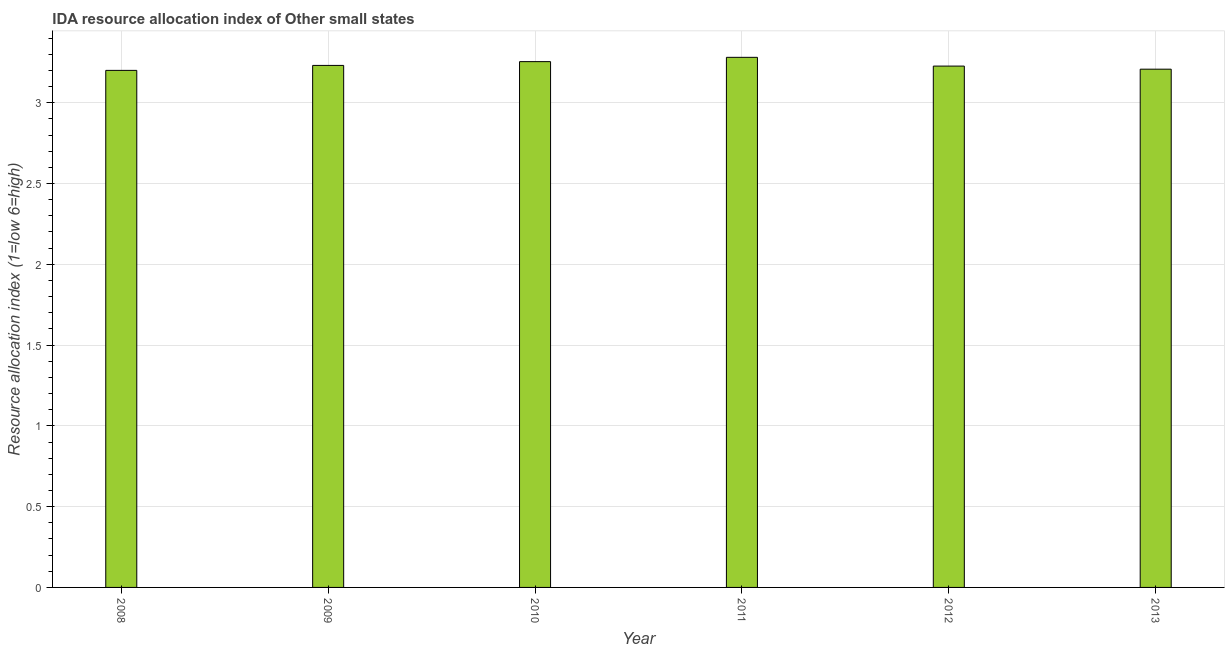Does the graph contain any zero values?
Provide a short and direct response. No. Does the graph contain grids?
Make the answer very short. Yes. What is the title of the graph?
Offer a very short reply. IDA resource allocation index of Other small states. What is the label or title of the X-axis?
Keep it short and to the point. Year. What is the label or title of the Y-axis?
Provide a short and direct response. Resource allocation index (1=low 6=high). What is the ida resource allocation index in 2013?
Your answer should be very brief. 3.21. Across all years, what is the maximum ida resource allocation index?
Keep it short and to the point. 3.28. Across all years, what is the minimum ida resource allocation index?
Offer a terse response. 3.2. In which year was the ida resource allocation index maximum?
Keep it short and to the point. 2011. In which year was the ida resource allocation index minimum?
Your response must be concise. 2008. What is the sum of the ida resource allocation index?
Your answer should be very brief. 19.4. What is the difference between the ida resource allocation index in 2011 and 2012?
Offer a very short reply. 0.05. What is the average ida resource allocation index per year?
Your answer should be very brief. 3.23. What is the median ida resource allocation index?
Provide a succinct answer. 3.23. In how many years, is the ida resource allocation index greater than 3.3 ?
Give a very brief answer. 0. Do a majority of the years between 2008 and 2012 (inclusive) have ida resource allocation index greater than 1.2 ?
Your answer should be compact. Yes. Is the ida resource allocation index in 2009 less than that in 2012?
Offer a very short reply. No. Is the difference between the ida resource allocation index in 2008 and 2012 greater than the difference between any two years?
Provide a succinct answer. No. What is the difference between the highest and the second highest ida resource allocation index?
Make the answer very short. 0.03. In how many years, is the ida resource allocation index greater than the average ida resource allocation index taken over all years?
Ensure brevity in your answer.  2. Are all the bars in the graph horizontal?
Your answer should be compact. No. What is the difference between two consecutive major ticks on the Y-axis?
Keep it short and to the point. 0.5. What is the Resource allocation index (1=low 6=high) of 2009?
Your answer should be compact. 3.23. What is the Resource allocation index (1=low 6=high) of 2010?
Make the answer very short. 3.25. What is the Resource allocation index (1=low 6=high) in 2011?
Ensure brevity in your answer.  3.28. What is the Resource allocation index (1=low 6=high) of 2012?
Offer a terse response. 3.23. What is the Resource allocation index (1=low 6=high) in 2013?
Your response must be concise. 3.21. What is the difference between the Resource allocation index (1=low 6=high) in 2008 and 2009?
Provide a succinct answer. -0.03. What is the difference between the Resource allocation index (1=low 6=high) in 2008 and 2010?
Ensure brevity in your answer.  -0.05. What is the difference between the Resource allocation index (1=low 6=high) in 2008 and 2011?
Provide a short and direct response. -0.08. What is the difference between the Resource allocation index (1=low 6=high) in 2008 and 2012?
Your answer should be very brief. -0.03. What is the difference between the Resource allocation index (1=low 6=high) in 2008 and 2013?
Provide a short and direct response. -0.01. What is the difference between the Resource allocation index (1=low 6=high) in 2009 and 2010?
Your answer should be very brief. -0.02. What is the difference between the Resource allocation index (1=low 6=high) in 2009 and 2011?
Your answer should be very brief. -0.05. What is the difference between the Resource allocation index (1=low 6=high) in 2009 and 2012?
Ensure brevity in your answer.  0. What is the difference between the Resource allocation index (1=low 6=high) in 2009 and 2013?
Your response must be concise. 0.02. What is the difference between the Resource allocation index (1=low 6=high) in 2010 and 2011?
Ensure brevity in your answer.  -0.03. What is the difference between the Resource allocation index (1=low 6=high) in 2010 and 2012?
Give a very brief answer. 0.03. What is the difference between the Resource allocation index (1=low 6=high) in 2010 and 2013?
Offer a very short reply. 0.05. What is the difference between the Resource allocation index (1=low 6=high) in 2011 and 2012?
Keep it short and to the point. 0.05. What is the difference between the Resource allocation index (1=low 6=high) in 2011 and 2013?
Make the answer very short. 0.07. What is the difference between the Resource allocation index (1=low 6=high) in 2012 and 2013?
Offer a terse response. 0.02. What is the ratio of the Resource allocation index (1=low 6=high) in 2008 to that in 2009?
Offer a very short reply. 0.99. What is the ratio of the Resource allocation index (1=low 6=high) in 2008 to that in 2011?
Your response must be concise. 0.97. What is the ratio of the Resource allocation index (1=low 6=high) in 2009 to that in 2010?
Ensure brevity in your answer.  0.99. What is the ratio of the Resource allocation index (1=low 6=high) in 2009 to that in 2011?
Provide a short and direct response. 0.98. What is the ratio of the Resource allocation index (1=low 6=high) in 2009 to that in 2013?
Provide a succinct answer. 1.01. What is the ratio of the Resource allocation index (1=low 6=high) in 2010 to that in 2011?
Offer a terse response. 0.99. What is the ratio of the Resource allocation index (1=low 6=high) in 2011 to that in 2012?
Your response must be concise. 1.02. 